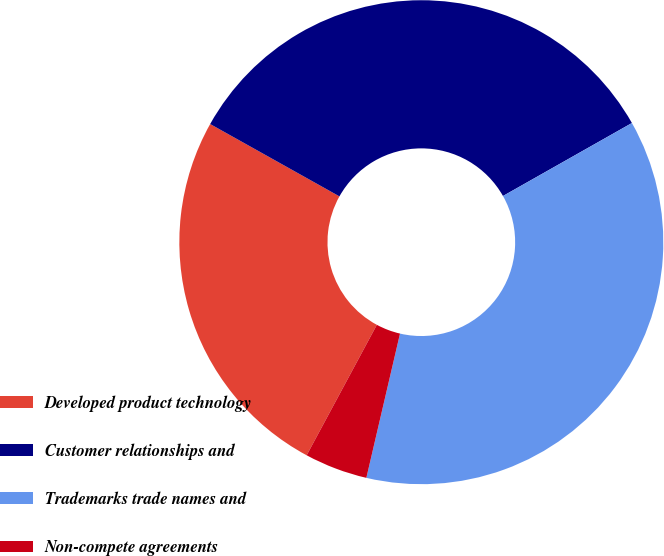Convert chart to OTSL. <chart><loc_0><loc_0><loc_500><loc_500><pie_chart><fcel>Developed product technology<fcel>Customer relationships and<fcel>Trademarks trade names and<fcel>Non-compete agreements<nl><fcel>25.26%<fcel>33.68%<fcel>36.84%<fcel>4.21%<nl></chart> 